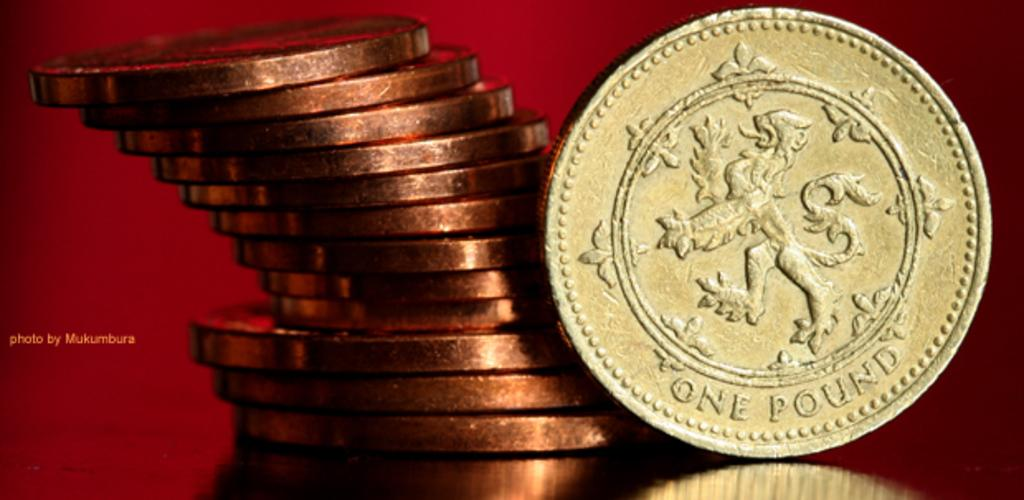<image>
Present a compact description of the photo's key features. A coin has an image of a dragon and is worth 1 pound. 